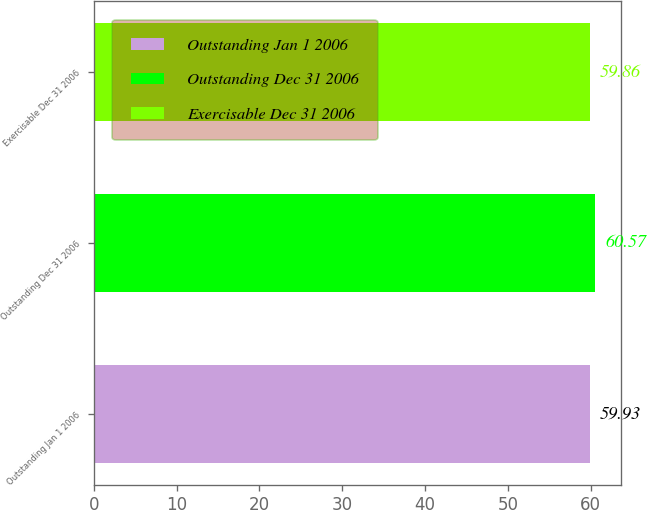Convert chart. <chart><loc_0><loc_0><loc_500><loc_500><bar_chart><fcel>Outstanding Jan 1 2006<fcel>Outstanding Dec 31 2006<fcel>Exercisable Dec 31 2006<nl><fcel>59.93<fcel>60.57<fcel>59.86<nl></chart> 